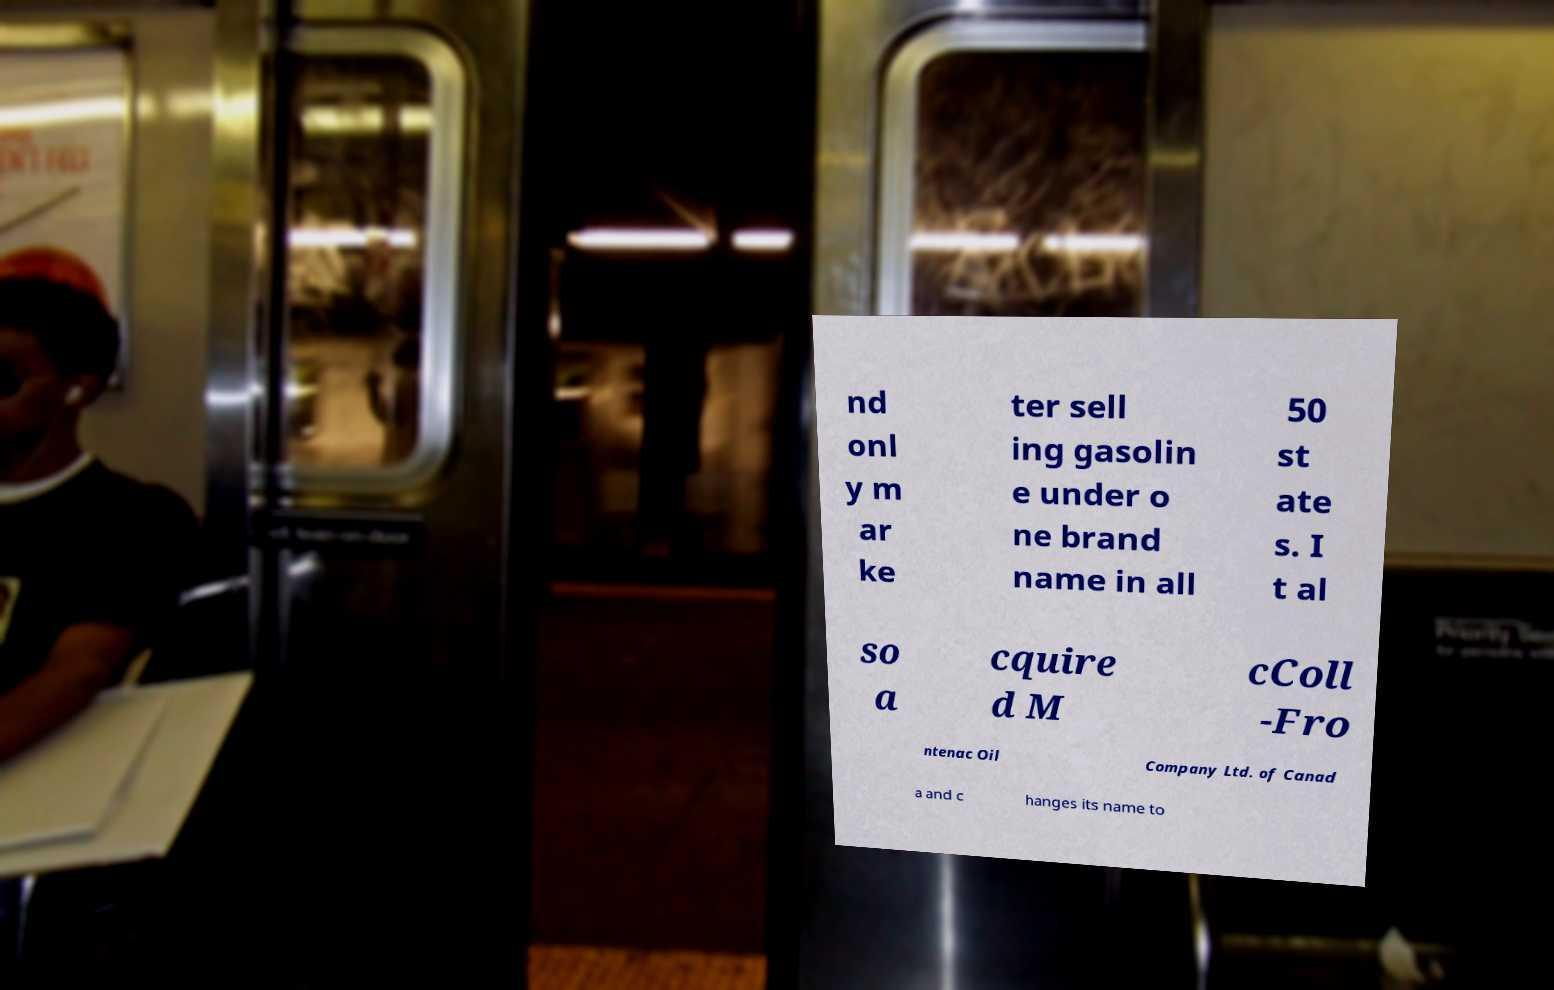What messages or text are displayed in this image? I need them in a readable, typed format. nd onl y m ar ke ter sell ing gasolin e under o ne brand name in all 50 st ate s. I t al so a cquire d M cColl -Fro ntenac Oil Company Ltd. of Canad a and c hanges its name to 